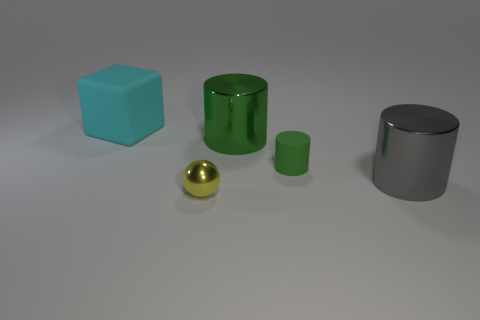There is a green thing behind the rubber cylinder; is it the same size as the metal object in front of the gray cylinder?
Your answer should be compact. No. Are there any cylinders to the right of the big shiny cylinder that is to the left of the tiny green rubber object behind the yellow metallic sphere?
Keep it short and to the point. Yes. Is the number of yellow metallic things that are to the left of the green rubber thing less than the number of matte cubes that are in front of the yellow metallic thing?
Make the answer very short. No. What shape is the yellow object that is made of the same material as the large gray thing?
Ensure brevity in your answer.  Sphere. What size is the metal cylinder in front of the large shiny thing that is on the left side of the large cylinder in front of the green metallic cylinder?
Offer a very short reply. Large. Is the number of metal spheres greater than the number of tiny cyan rubber things?
Give a very brief answer. Yes. There is a large metallic object in front of the tiny green cylinder; is it the same color as the matte object in front of the large block?
Make the answer very short. No. Does the big cylinder that is on the left side of the gray object have the same material as the tiny thing that is behind the big gray thing?
Offer a very short reply. No. What number of cylinders are the same size as the metal sphere?
Your response must be concise. 1. Are there fewer small balls than blue rubber objects?
Provide a succinct answer. No. 